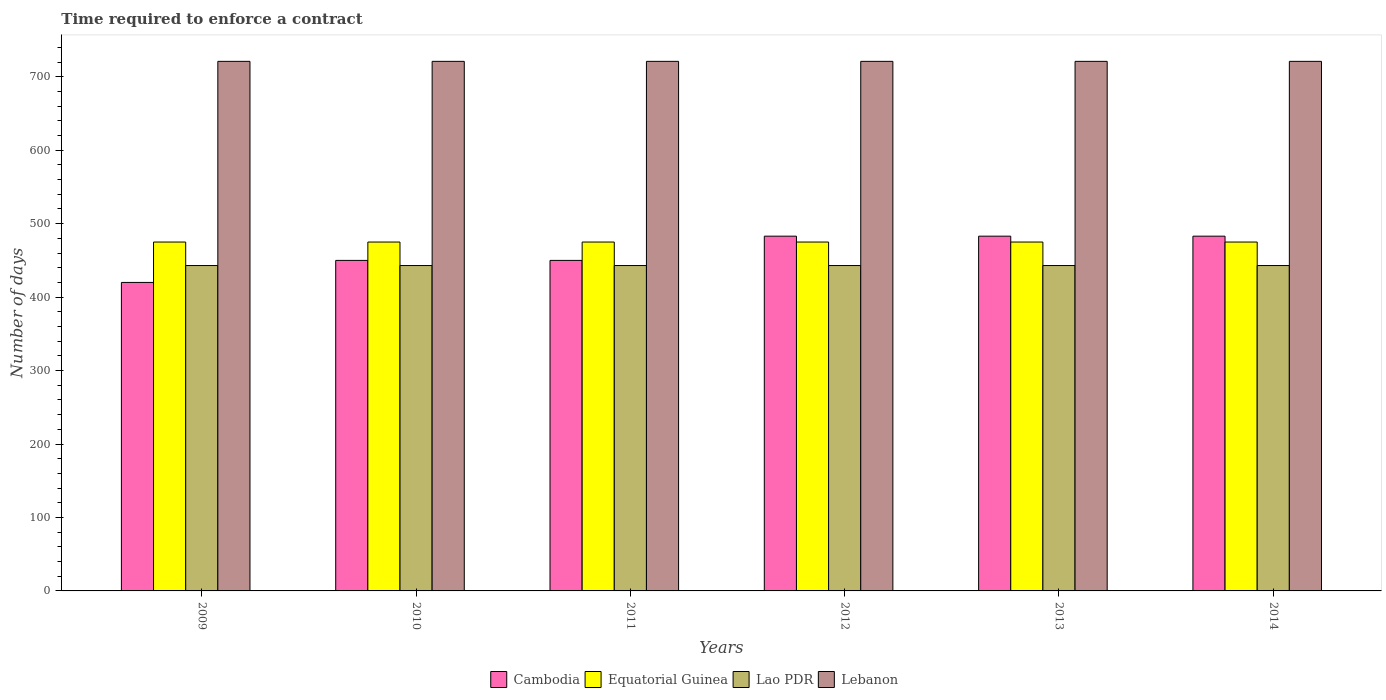How many groups of bars are there?
Offer a very short reply. 6. Are the number of bars per tick equal to the number of legend labels?
Give a very brief answer. Yes. How many bars are there on the 6th tick from the left?
Ensure brevity in your answer.  4. How many bars are there on the 6th tick from the right?
Provide a short and direct response. 4. What is the number of days required to enforce a contract in Lebanon in 2009?
Provide a succinct answer. 721. Across all years, what is the maximum number of days required to enforce a contract in Lebanon?
Keep it short and to the point. 721. Across all years, what is the minimum number of days required to enforce a contract in Cambodia?
Provide a succinct answer. 420. What is the total number of days required to enforce a contract in Cambodia in the graph?
Your response must be concise. 2769. What is the difference between the number of days required to enforce a contract in Lao PDR in 2011 and that in 2012?
Provide a succinct answer. 0. What is the average number of days required to enforce a contract in Lebanon per year?
Your answer should be very brief. 721. In the year 2013, what is the difference between the number of days required to enforce a contract in Lao PDR and number of days required to enforce a contract in Cambodia?
Provide a short and direct response. -40. Is the number of days required to enforce a contract in Lao PDR in 2009 less than that in 2011?
Offer a terse response. No. Is the difference between the number of days required to enforce a contract in Lao PDR in 2010 and 2013 greater than the difference between the number of days required to enforce a contract in Cambodia in 2010 and 2013?
Provide a short and direct response. Yes. What is the difference between the highest and the second highest number of days required to enforce a contract in Cambodia?
Keep it short and to the point. 0. What is the difference between the highest and the lowest number of days required to enforce a contract in Cambodia?
Offer a very short reply. 63. In how many years, is the number of days required to enforce a contract in Cambodia greater than the average number of days required to enforce a contract in Cambodia taken over all years?
Make the answer very short. 3. What does the 3rd bar from the left in 2014 represents?
Offer a very short reply. Lao PDR. What does the 2nd bar from the right in 2013 represents?
Offer a very short reply. Lao PDR. Is it the case that in every year, the sum of the number of days required to enforce a contract in Lao PDR and number of days required to enforce a contract in Lebanon is greater than the number of days required to enforce a contract in Cambodia?
Your response must be concise. Yes. How many bars are there?
Give a very brief answer. 24. What is the difference between two consecutive major ticks on the Y-axis?
Provide a short and direct response. 100. Does the graph contain grids?
Offer a terse response. No. Where does the legend appear in the graph?
Offer a terse response. Bottom center. How are the legend labels stacked?
Offer a terse response. Horizontal. What is the title of the graph?
Provide a succinct answer. Time required to enforce a contract. What is the label or title of the Y-axis?
Offer a terse response. Number of days. What is the Number of days of Cambodia in 2009?
Ensure brevity in your answer.  420. What is the Number of days of Equatorial Guinea in 2009?
Offer a very short reply. 475. What is the Number of days in Lao PDR in 2009?
Make the answer very short. 443. What is the Number of days in Lebanon in 2009?
Provide a succinct answer. 721. What is the Number of days in Cambodia in 2010?
Your response must be concise. 450. What is the Number of days of Equatorial Guinea in 2010?
Your answer should be compact. 475. What is the Number of days of Lao PDR in 2010?
Keep it short and to the point. 443. What is the Number of days in Lebanon in 2010?
Your answer should be very brief. 721. What is the Number of days in Cambodia in 2011?
Provide a short and direct response. 450. What is the Number of days of Equatorial Guinea in 2011?
Offer a terse response. 475. What is the Number of days in Lao PDR in 2011?
Provide a succinct answer. 443. What is the Number of days of Lebanon in 2011?
Make the answer very short. 721. What is the Number of days in Cambodia in 2012?
Provide a succinct answer. 483. What is the Number of days in Equatorial Guinea in 2012?
Offer a terse response. 475. What is the Number of days in Lao PDR in 2012?
Offer a terse response. 443. What is the Number of days in Lebanon in 2012?
Give a very brief answer. 721. What is the Number of days in Cambodia in 2013?
Provide a short and direct response. 483. What is the Number of days of Equatorial Guinea in 2013?
Your response must be concise. 475. What is the Number of days of Lao PDR in 2013?
Your response must be concise. 443. What is the Number of days of Lebanon in 2013?
Make the answer very short. 721. What is the Number of days of Cambodia in 2014?
Provide a succinct answer. 483. What is the Number of days of Equatorial Guinea in 2014?
Your answer should be very brief. 475. What is the Number of days in Lao PDR in 2014?
Keep it short and to the point. 443. What is the Number of days in Lebanon in 2014?
Ensure brevity in your answer.  721. Across all years, what is the maximum Number of days in Cambodia?
Your answer should be very brief. 483. Across all years, what is the maximum Number of days in Equatorial Guinea?
Offer a very short reply. 475. Across all years, what is the maximum Number of days in Lao PDR?
Your answer should be compact. 443. Across all years, what is the maximum Number of days of Lebanon?
Your response must be concise. 721. Across all years, what is the minimum Number of days in Cambodia?
Make the answer very short. 420. Across all years, what is the minimum Number of days of Equatorial Guinea?
Offer a terse response. 475. Across all years, what is the minimum Number of days in Lao PDR?
Your answer should be compact. 443. Across all years, what is the minimum Number of days in Lebanon?
Provide a succinct answer. 721. What is the total Number of days of Cambodia in the graph?
Offer a terse response. 2769. What is the total Number of days of Equatorial Guinea in the graph?
Your response must be concise. 2850. What is the total Number of days of Lao PDR in the graph?
Offer a very short reply. 2658. What is the total Number of days in Lebanon in the graph?
Provide a short and direct response. 4326. What is the difference between the Number of days in Cambodia in 2009 and that in 2010?
Offer a terse response. -30. What is the difference between the Number of days in Lao PDR in 2009 and that in 2010?
Ensure brevity in your answer.  0. What is the difference between the Number of days of Lebanon in 2009 and that in 2010?
Offer a terse response. 0. What is the difference between the Number of days in Lebanon in 2009 and that in 2011?
Offer a terse response. 0. What is the difference between the Number of days of Cambodia in 2009 and that in 2012?
Your response must be concise. -63. What is the difference between the Number of days in Lebanon in 2009 and that in 2012?
Your answer should be compact. 0. What is the difference between the Number of days in Cambodia in 2009 and that in 2013?
Your answer should be very brief. -63. What is the difference between the Number of days in Equatorial Guinea in 2009 and that in 2013?
Your response must be concise. 0. What is the difference between the Number of days in Cambodia in 2009 and that in 2014?
Ensure brevity in your answer.  -63. What is the difference between the Number of days in Equatorial Guinea in 2009 and that in 2014?
Provide a succinct answer. 0. What is the difference between the Number of days in Lao PDR in 2010 and that in 2011?
Offer a terse response. 0. What is the difference between the Number of days in Cambodia in 2010 and that in 2012?
Keep it short and to the point. -33. What is the difference between the Number of days of Lao PDR in 2010 and that in 2012?
Provide a succinct answer. 0. What is the difference between the Number of days of Lebanon in 2010 and that in 2012?
Make the answer very short. 0. What is the difference between the Number of days in Cambodia in 2010 and that in 2013?
Ensure brevity in your answer.  -33. What is the difference between the Number of days in Lao PDR in 2010 and that in 2013?
Ensure brevity in your answer.  0. What is the difference between the Number of days in Lebanon in 2010 and that in 2013?
Your answer should be compact. 0. What is the difference between the Number of days in Cambodia in 2010 and that in 2014?
Your answer should be compact. -33. What is the difference between the Number of days in Equatorial Guinea in 2010 and that in 2014?
Keep it short and to the point. 0. What is the difference between the Number of days of Cambodia in 2011 and that in 2012?
Provide a short and direct response. -33. What is the difference between the Number of days of Equatorial Guinea in 2011 and that in 2012?
Provide a succinct answer. 0. What is the difference between the Number of days in Lao PDR in 2011 and that in 2012?
Your answer should be compact. 0. What is the difference between the Number of days of Lebanon in 2011 and that in 2012?
Offer a very short reply. 0. What is the difference between the Number of days of Cambodia in 2011 and that in 2013?
Your response must be concise. -33. What is the difference between the Number of days of Equatorial Guinea in 2011 and that in 2013?
Your answer should be very brief. 0. What is the difference between the Number of days in Lao PDR in 2011 and that in 2013?
Make the answer very short. 0. What is the difference between the Number of days of Cambodia in 2011 and that in 2014?
Ensure brevity in your answer.  -33. What is the difference between the Number of days in Equatorial Guinea in 2012 and that in 2013?
Your response must be concise. 0. What is the difference between the Number of days in Lao PDR in 2012 and that in 2013?
Offer a very short reply. 0. What is the difference between the Number of days of Lebanon in 2012 and that in 2013?
Your answer should be very brief. 0. What is the difference between the Number of days in Cambodia in 2012 and that in 2014?
Your answer should be very brief. 0. What is the difference between the Number of days in Lao PDR in 2012 and that in 2014?
Give a very brief answer. 0. What is the difference between the Number of days of Lebanon in 2012 and that in 2014?
Give a very brief answer. 0. What is the difference between the Number of days of Cambodia in 2013 and that in 2014?
Give a very brief answer. 0. What is the difference between the Number of days in Equatorial Guinea in 2013 and that in 2014?
Give a very brief answer. 0. What is the difference between the Number of days of Lao PDR in 2013 and that in 2014?
Provide a succinct answer. 0. What is the difference between the Number of days in Cambodia in 2009 and the Number of days in Equatorial Guinea in 2010?
Provide a short and direct response. -55. What is the difference between the Number of days in Cambodia in 2009 and the Number of days in Lao PDR in 2010?
Your answer should be compact. -23. What is the difference between the Number of days in Cambodia in 2009 and the Number of days in Lebanon in 2010?
Offer a very short reply. -301. What is the difference between the Number of days of Equatorial Guinea in 2009 and the Number of days of Lebanon in 2010?
Keep it short and to the point. -246. What is the difference between the Number of days in Lao PDR in 2009 and the Number of days in Lebanon in 2010?
Keep it short and to the point. -278. What is the difference between the Number of days in Cambodia in 2009 and the Number of days in Equatorial Guinea in 2011?
Your answer should be compact. -55. What is the difference between the Number of days of Cambodia in 2009 and the Number of days of Lebanon in 2011?
Provide a succinct answer. -301. What is the difference between the Number of days of Equatorial Guinea in 2009 and the Number of days of Lao PDR in 2011?
Your response must be concise. 32. What is the difference between the Number of days of Equatorial Guinea in 2009 and the Number of days of Lebanon in 2011?
Your answer should be very brief. -246. What is the difference between the Number of days in Lao PDR in 2009 and the Number of days in Lebanon in 2011?
Your answer should be very brief. -278. What is the difference between the Number of days of Cambodia in 2009 and the Number of days of Equatorial Guinea in 2012?
Your response must be concise. -55. What is the difference between the Number of days in Cambodia in 2009 and the Number of days in Lao PDR in 2012?
Provide a short and direct response. -23. What is the difference between the Number of days of Cambodia in 2009 and the Number of days of Lebanon in 2012?
Your answer should be very brief. -301. What is the difference between the Number of days in Equatorial Guinea in 2009 and the Number of days in Lebanon in 2012?
Keep it short and to the point. -246. What is the difference between the Number of days of Lao PDR in 2009 and the Number of days of Lebanon in 2012?
Your answer should be very brief. -278. What is the difference between the Number of days in Cambodia in 2009 and the Number of days in Equatorial Guinea in 2013?
Your response must be concise. -55. What is the difference between the Number of days of Cambodia in 2009 and the Number of days of Lao PDR in 2013?
Keep it short and to the point. -23. What is the difference between the Number of days of Cambodia in 2009 and the Number of days of Lebanon in 2013?
Make the answer very short. -301. What is the difference between the Number of days in Equatorial Guinea in 2009 and the Number of days in Lebanon in 2013?
Provide a succinct answer. -246. What is the difference between the Number of days in Lao PDR in 2009 and the Number of days in Lebanon in 2013?
Offer a very short reply. -278. What is the difference between the Number of days in Cambodia in 2009 and the Number of days in Equatorial Guinea in 2014?
Your answer should be compact. -55. What is the difference between the Number of days of Cambodia in 2009 and the Number of days of Lao PDR in 2014?
Provide a short and direct response. -23. What is the difference between the Number of days in Cambodia in 2009 and the Number of days in Lebanon in 2014?
Your response must be concise. -301. What is the difference between the Number of days of Equatorial Guinea in 2009 and the Number of days of Lebanon in 2014?
Make the answer very short. -246. What is the difference between the Number of days of Lao PDR in 2009 and the Number of days of Lebanon in 2014?
Provide a short and direct response. -278. What is the difference between the Number of days in Cambodia in 2010 and the Number of days in Equatorial Guinea in 2011?
Offer a terse response. -25. What is the difference between the Number of days in Cambodia in 2010 and the Number of days in Lao PDR in 2011?
Provide a succinct answer. 7. What is the difference between the Number of days in Cambodia in 2010 and the Number of days in Lebanon in 2011?
Give a very brief answer. -271. What is the difference between the Number of days of Equatorial Guinea in 2010 and the Number of days of Lao PDR in 2011?
Provide a short and direct response. 32. What is the difference between the Number of days in Equatorial Guinea in 2010 and the Number of days in Lebanon in 2011?
Make the answer very short. -246. What is the difference between the Number of days of Lao PDR in 2010 and the Number of days of Lebanon in 2011?
Give a very brief answer. -278. What is the difference between the Number of days of Cambodia in 2010 and the Number of days of Equatorial Guinea in 2012?
Ensure brevity in your answer.  -25. What is the difference between the Number of days of Cambodia in 2010 and the Number of days of Lebanon in 2012?
Your response must be concise. -271. What is the difference between the Number of days of Equatorial Guinea in 2010 and the Number of days of Lebanon in 2012?
Your answer should be very brief. -246. What is the difference between the Number of days in Lao PDR in 2010 and the Number of days in Lebanon in 2012?
Your response must be concise. -278. What is the difference between the Number of days of Cambodia in 2010 and the Number of days of Equatorial Guinea in 2013?
Ensure brevity in your answer.  -25. What is the difference between the Number of days of Cambodia in 2010 and the Number of days of Lebanon in 2013?
Your answer should be very brief. -271. What is the difference between the Number of days of Equatorial Guinea in 2010 and the Number of days of Lao PDR in 2013?
Offer a very short reply. 32. What is the difference between the Number of days of Equatorial Guinea in 2010 and the Number of days of Lebanon in 2013?
Provide a short and direct response. -246. What is the difference between the Number of days in Lao PDR in 2010 and the Number of days in Lebanon in 2013?
Keep it short and to the point. -278. What is the difference between the Number of days in Cambodia in 2010 and the Number of days in Lebanon in 2014?
Keep it short and to the point. -271. What is the difference between the Number of days in Equatorial Guinea in 2010 and the Number of days in Lebanon in 2014?
Provide a succinct answer. -246. What is the difference between the Number of days in Lao PDR in 2010 and the Number of days in Lebanon in 2014?
Keep it short and to the point. -278. What is the difference between the Number of days in Cambodia in 2011 and the Number of days in Equatorial Guinea in 2012?
Provide a short and direct response. -25. What is the difference between the Number of days in Cambodia in 2011 and the Number of days in Lebanon in 2012?
Keep it short and to the point. -271. What is the difference between the Number of days of Equatorial Guinea in 2011 and the Number of days of Lao PDR in 2012?
Your answer should be compact. 32. What is the difference between the Number of days of Equatorial Guinea in 2011 and the Number of days of Lebanon in 2012?
Offer a very short reply. -246. What is the difference between the Number of days of Lao PDR in 2011 and the Number of days of Lebanon in 2012?
Offer a terse response. -278. What is the difference between the Number of days of Cambodia in 2011 and the Number of days of Lebanon in 2013?
Your answer should be compact. -271. What is the difference between the Number of days in Equatorial Guinea in 2011 and the Number of days in Lebanon in 2013?
Keep it short and to the point. -246. What is the difference between the Number of days in Lao PDR in 2011 and the Number of days in Lebanon in 2013?
Give a very brief answer. -278. What is the difference between the Number of days in Cambodia in 2011 and the Number of days in Lebanon in 2014?
Your answer should be compact. -271. What is the difference between the Number of days in Equatorial Guinea in 2011 and the Number of days in Lebanon in 2014?
Offer a very short reply. -246. What is the difference between the Number of days in Lao PDR in 2011 and the Number of days in Lebanon in 2014?
Provide a short and direct response. -278. What is the difference between the Number of days in Cambodia in 2012 and the Number of days in Lebanon in 2013?
Make the answer very short. -238. What is the difference between the Number of days of Equatorial Guinea in 2012 and the Number of days of Lao PDR in 2013?
Keep it short and to the point. 32. What is the difference between the Number of days in Equatorial Guinea in 2012 and the Number of days in Lebanon in 2013?
Make the answer very short. -246. What is the difference between the Number of days in Lao PDR in 2012 and the Number of days in Lebanon in 2013?
Give a very brief answer. -278. What is the difference between the Number of days of Cambodia in 2012 and the Number of days of Lebanon in 2014?
Your answer should be compact. -238. What is the difference between the Number of days of Equatorial Guinea in 2012 and the Number of days of Lao PDR in 2014?
Provide a short and direct response. 32. What is the difference between the Number of days in Equatorial Guinea in 2012 and the Number of days in Lebanon in 2014?
Give a very brief answer. -246. What is the difference between the Number of days in Lao PDR in 2012 and the Number of days in Lebanon in 2014?
Your response must be concise. -278. What is the difference between the Number of days in Cambodia in 2013 and the Number of days in Lebanon in 2014?
Offer a terse response. -238. What is the difference between the Number of days of Equatorial Guinea in 2013 and the Number of days of Lao PDR in 2014?
Make the answer very short. 32. What is the difference between the Number of days in Equatorial Guinea in 2013 and the Number of days in Lebanon in 2014?
Your answer should be compact. -246. What is the difference between the Number of days in Lao PDR in 2013 and the Number of days in Lebanon in 2014?
Make the answer very short. -278. What is the average Number of days of Cambodia per year?
Ensure brevity in your answer.  461.5. What is the average Number of days in Equatorial Guinea per year?
Your answer should be very brief. 475. What is the average Number of days of Lao PDR per year?
Give a very brief answer. 443. What is the average Number of days in Lebanon per year?
Your answer should be compact. 721. In the year 2009, what is the difference between the Number of days in Cambodia and Number of days in Equatorial Guinea?
Your response must be concise. -55. In the year 2009, what is the difference between the Number of days in Cambodia and Number of days in Lebanon?
Provide a short and direct response. -301. In the year 2009, what is the difference between the Number of days in Equatorial Guinea and Number of days in Lao PDR?
Offer a terse response. 32. In the year 2009, what is the difference between the Number of days in Equatorial Guinea and Number of days in Lebanon?
Your answer should be compact. -246. In the year 2009, what is the difference between the Number of days of Lao PDR and Number of days of Lebanon?
Ensure brevity in your answer.  -278. In the year 2010, what is the difference between the Number of days in Cambodia and Number of days in Lebanon?
Offer a very short reply. -271. In the year 2010, what is the difference between the Number of days of Equatorial Guinea and Number of days of Lebanon?
Ensure brevity in your answer.  -246. In the year 2010, what is the difference between the Number of days in Lao PDR and Number of days in Lebanon?
Your response must be concise. -278. In the year 2011, what is the difference between the Number of days in Cambodia and Number of days in Equatorial Guinea?
Provide a short and direct response. -25. In the year 2011, what is the difference between the Number of days of Cambodia and Number of days of Lebanon?
Give a very brief answer. -271. In the year 2011, what is the difference between the Number of days of Equatorial Guinea and Number of days of Lao PDR?
Offer a terse response. 32. In the year 2011, what is the difference between the Number of days in Equatorial Guinea and Number of days in Lebanon?
Offer a very short reply. -246. In the year 2011, what is the difference between the Number of days in Lao PDR and Number of days in Lebanon?
Your response must be concise. -278. In the year 2012, what is the difference between the Number of days in Cambodia and Number of days in Lao PDR?
Your answer should be compact. 40. In the year 2012, what is the difference between the Number of days of Cambodia and Number of days of Lebanon?
Your answer should be compact. -238. In the year 2012, what is the difference between the Number of days of Equatorial Guinea and Number of days of Lebanon?
Ensure brevity in your answer.  -246. In the year 2012, what is the difference between the Number of days of Lao PDR and Number of days of Lebanon?
Offer a very short reply. -278. In the year 2013, what is the difference between the Number of days of Cambodia and Number of days of Equatorial Guinea?
Your answer should be very brief. 8. In the year 2013, what is the difference between the Number of days in Cambodia and Number of days in Lao PDR?
Give a very brief answer. 40. In the year 2013, what is the difference between the Number of days of Cambodia and Number of days of Lebanon?
Keep it short and to the point. -238. In the year 2013, what is the difference between the Number of days in Equatorial Guinea and Number of days in Lebanon?
Give a very brief answer. -246. In the year 2013, what is the difference between the Number of days in Lao PDR and Number of days in Lebanon?
Offer a very short reply. -278. In the year 2014, what is the difference between the Number of days of Cambodia and Number of days of Equatorial Guinea?
Your response must be concise. 8. In the year 2014, what is the difference between the Number of days of Cambodia and Number of days of Lao PDR?
Ensure brevity in your answer.  40. In the year 2014, what is the difference between the Number of days in Cambodia and Number of days in Lebanon?
Offer a very short reply. -238. In the year 2014, what is the difference between the Number of days in Equatorial Guinea and Number of days in Lebanon?
Make the answer very short. -246. In the year 2014, what is the difference between the Number of days of Lao PDR and Number of days of Lebanon?
Give a very brief answer. -278. What is the ratio of the Number of days of Cambodia in 2009 to that in 2010?
Provide a succinct answer. 0.93. What is the ratio of the Number of days of Equatorial Guinea in 2009 to that in 2010?
Give a very brief answer. 1. What is the ratio of the Number of days of Lebanon in 2009 to that in 2010?
Ensure brevity in your answer.  1. What is the ratio of the Number of days of Equatorial Guinea in 2009 to that in 2011?
Offer a very short reply. 1. What is the ratio of the Number of days of Lebanon in 2009 to that in 2011?
Give a very brief answer. 1. What is the ratio of the Number of days in Cambodia in 2009 to that in 2012?
Your response must be concise. 0.87. What is the ratio of the Number of days in Cambodia in 2009 to that in 2013?
Give a very brief answer. 0.87. What is the ratio of the Number of days in Lao PDR in 2009 to that in 2013?
Your answer should be compact. 1. What is the ratio of the Number of days of Lebanon in 2009 to that in 2013?
Your response must be concise. 1. What is the ratio of the Number of days of Cambodia in 2009 to that in 2014?
Your answer should be compact. 0.87. What is the ratio of the Number of days of Lao PDR in 2009 to that in 2014?
Your response must be concise. 1. What is the ratio of the Number of days of Lebanon in 2010 to that in 2011?
Provide a short and direct response. 1. What is the ratio of the Number of days of Cambodia in 2010 to that in 2012?
Ensure brevity in your answer.  0.93. What is the ratio of the Number of days in Cambodia in 2010 to that in 2013?
Your response must be concise. 0.93. What is the ratio of the Number of days in Lebanon in 2010 to that in 2013?
Your answer should be very brief. 1. What is the ratio of the Number of days in Cambodia in 2010 to that in 2014?
Your answer should be compact. 0.93. What is the ratio of the Number of days of Lao PDR in 2010 to that in 2014?
Provide a short and direct response. 1. What is the ratio of the Number of days of Lebanon in 2010 to that in 2014?
Your answer should be very brief. 1. What is the ratio of the Number of days of Cambodia in 2011 to that in 2012?
Provide a succinct answer. 0.93. What is the ratio of the Number of days of Lao PDR in 2011 to that in 2012?
Give a very brief answer. 1. What is the ratio of the Number of days in Lebanon in 2011 to that in 2012?
Offer a very short reply. 1. What is the ratio of the Number of days of Cambodia in 2011 to that in 2013?
Your answer should be very brief. 0.93. What is the ratio of the Number of days in Equatorial Guinea in 2011 to that in 2013?
Your answer should be compact. 1. What is the ratio of the Number of days in Lebanon in 2011 to that in 2013?
Give a very brief answer. 1. What is the ratio of the Number of days of Cambodia in 2011 to that in 2014?
Your answer should be very brief. 0.93. What is the ratio of the Number of days in Lao PDR in 2012 to that in 2013?
Provide a succinct answer. 1. What is the ratio of the Number of days in Lebanon in 2012 to that in 2013?
Your answer should be very brief. 1. What is the ratio of the Number of days of Cambodia in 2012 to that in 2014?
Make the answer very short. 1. What is the ratio of the Number of days in Lebanon in 2012 to that in 2014?
Offer a terse response. 1. What is the ratio of the Number of days in Cambodia in 2013 to that in 2014?
Your response must be concise. 1. What is the difference between the highest and the second highest Number of days of Cambodia?
Provide a succinct answer. 0. What is the difference between the highest and the second highest Number of days of Lebanon?
Offer a terse response. 0. What is the difference between the highest and the lowest Number of days of Cambodia?
Ensure brevity in your answer.  63. What is the difference between the highest and the lowest Number of days in Lao PDR?
Keep it short and to the point. 0. 